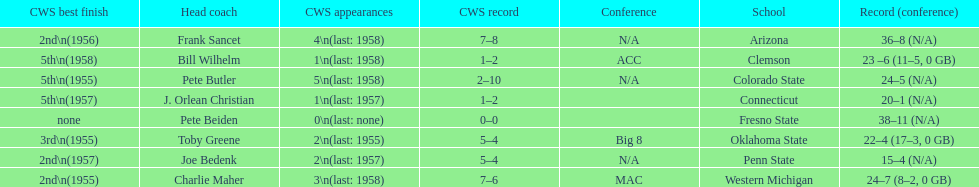Which team did not have more than 16 wins? Penn State. 